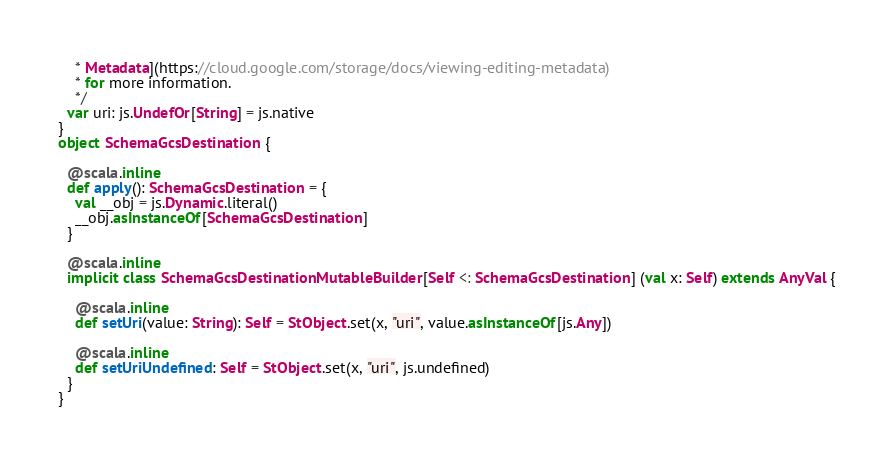Convert code to text. <code><loc_0><loc_0><loc_500><loc_500><_Scala_>    * Metadata](https://cloud.google.com/storage/docs/viewing-editing-metadata)
    * for more information.
    */
  var uri: js.UndefOr[String] = js.native
}
object SchemaGcsDestination {
  
  @scala.inline
  def apply(): SchemaGcsDestination = {
    val __obj = js.Dynamic.literal()
    __obj.asInstanceOf[SchemaGcsDestination]
  }
  
  @scala.inline
  implicit class SchemaGcsDestinationMutableBuilder[Self <: SchemaGcsDestination] (val x: Self) extends AnyVal {
    
    @scala.inline
    def setUri(value: String): Self = StObject.set(x, "uri", value.asInstanceOf[js.Any])
    
    @scala.inline
    def setUriUndefined: Self = StObject.set(x, "uri", js.undefined)
  }
}
</code> 